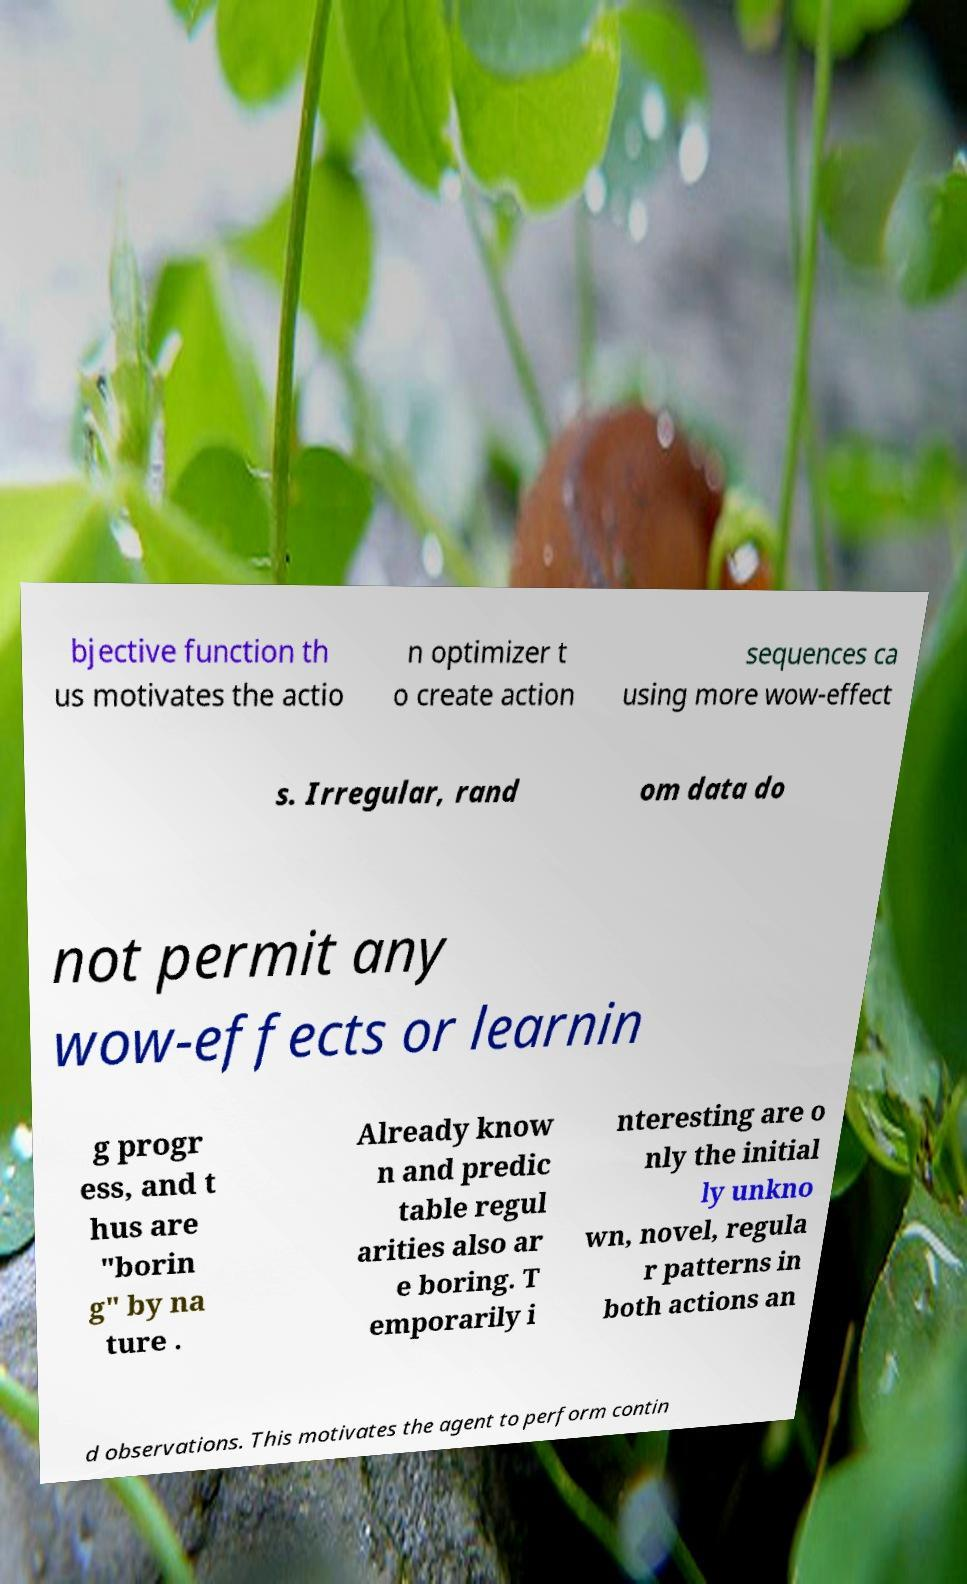Can you read and provide the text displayed in the image?This photo seems to have some interesting text. Can you extract and type it out for me? bjective function th us motivates the actio n optimizer t o create action sequences ca using more wow-effect s. Irregular, rand om data do not permit any wow-effects or learnin g progr ess, and t hus are "borin g" by na ture . Already know n and predic table regul arities also ar e boring. T emporarily i nteresting are o nly the initial ly unkno wn, novel, regula r patterns in both actions an d observations. This motivates the agent to perform contin 